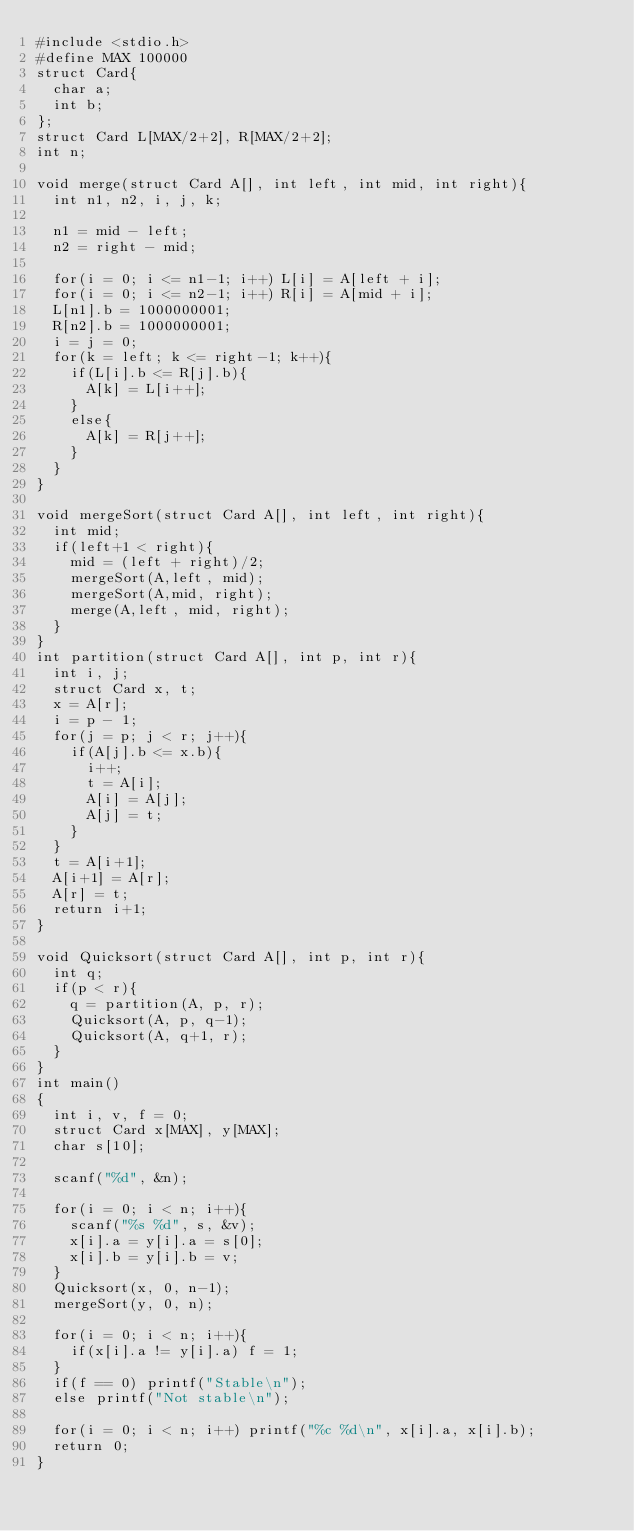Convert code to text. <code><loc_0><loc_0><loc_500><loc_500><_C_>#include <stdio.h>
#define MAX 100000
struct Card{
  char a;
  int b;
};
struct Card L[MAX/2+2], R[MAX/2+2];
int n;
 
void merge(struct Card A[], int left, int mid, int right){
  int n1, n2, i, j, k;
 
  n1 = mid - left;
  n2 = right - mid;
 
  for(i = 0; i <= n1-1; i++) L[i] = A[left + i];
  for(i = 0; i <= n2-1; i++) R[i] = A[mid + i];
  L[n1].b = 1000000001;
  R[n2].b = 1000000001;
  i = j = 0;
  for(k = left; k <= right-1; k++){
    if(L[i].b <= R[j].b){
      A[k] = L[i++];
    }
    else{
      A[k] = R[j++];
    }
  }
}
 
void mergeSort(struct Card A[], int left, int right){
  int mid;
  if(left+1 < right){
    mid = (left + right)/2;
    mergeSort(A,left, mid);
    mergeSort(A,mid, right);
    merge(A,left, mid, right);
  }
}
int partition(struct Card A[], int p, int r){
  int i, j;
  struct Card x, t;
  x = A[r];
  i = p - 1;
  for(j = p; j < r; j++){
    if(A[j].b <= x.b){
      i++;
      t = A[i];
      A[i] = A[j];
      A[j] = t;
    }
  }
  t = A[i+1];
  A[i+1] = A[r];
  A[r] = t;
  return i+1;
}
 
void Quicksort(struct Card A[], int p, int r){
  int q;
  if(p < r){
    q = partition(A, p, r);
    Quicksort(A, p, q-1);
    Quicksort(A, q+1, r);
  }
}
int main()
{
  int i, v, f = 0;
  struct Card x[MAX], y[MAX];
  char s[10];
 
  scanf("%d", &n);
 
  for(i = 0; i < n; i++){
    scanf("%s %d", s, &v);
    x[i].a = y[i].a = s[0];
    x[i].b = y[i].b = v;
  }
  Quicksort(x, 0, n-1);
  mergeSort(y, 0, n);
 
  for(i = 0; i < n; i++){
    if(x[i].a != y[i].a) f = 1;
  }
  if(f == 0) printf("Stable\n");
  else printf("Not stable\n");
 
  for(i = 0; i < n; i++) printf("%c %d\n", x[i].a, x[i].b);
  return 0;
}</code> 